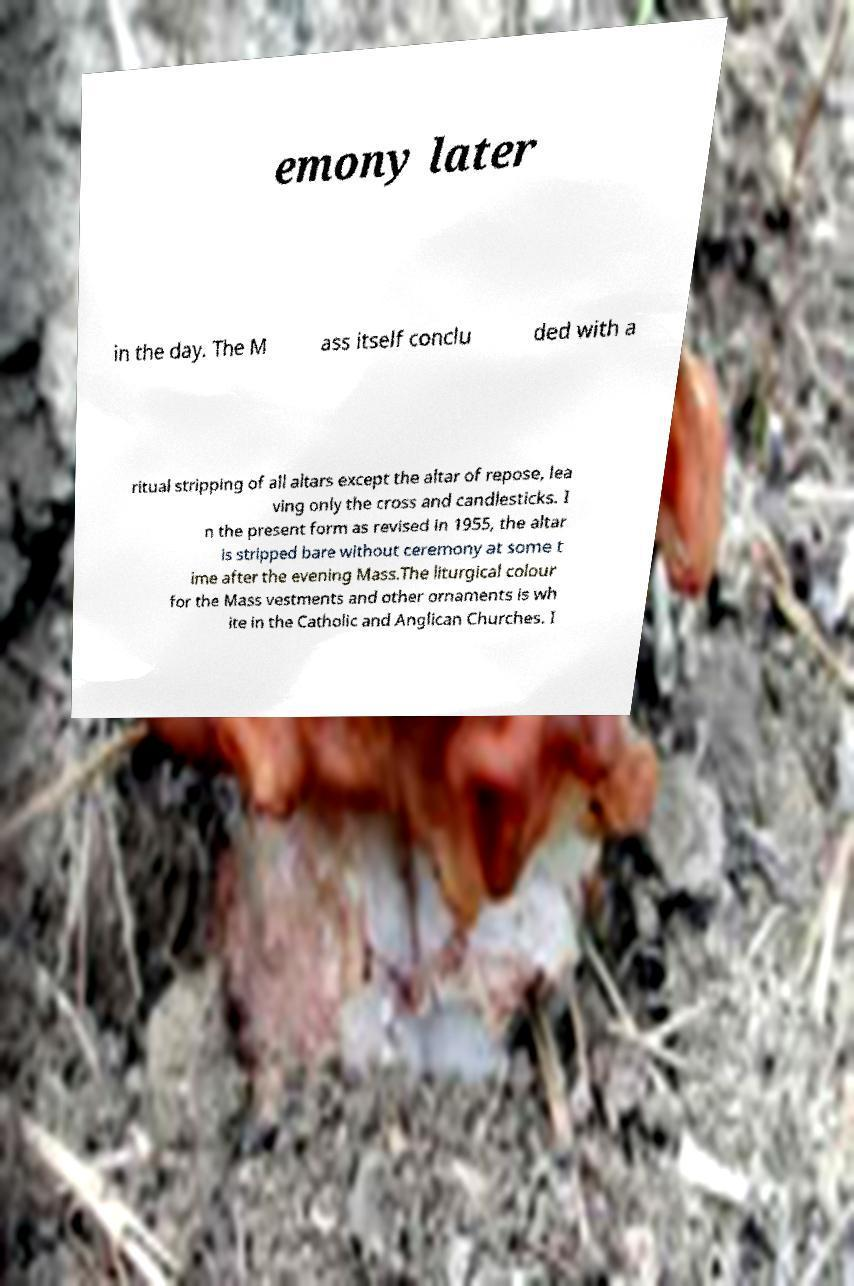What messages or text are displayed in this image? I need them in a readable, typed format. emony later in the day. The M ass itself conclu ded with a ritual stripping of all altars except the altar of repose, lea ving only the cross and candlesticks. I n the present form as revised in 1955, the altar is stripped bare without ceremony at some t ime after the evening Mass.The liturgical colour for the Mass vestments and other ornaments is wh ite in the Catholic and Anglican Churches. I 